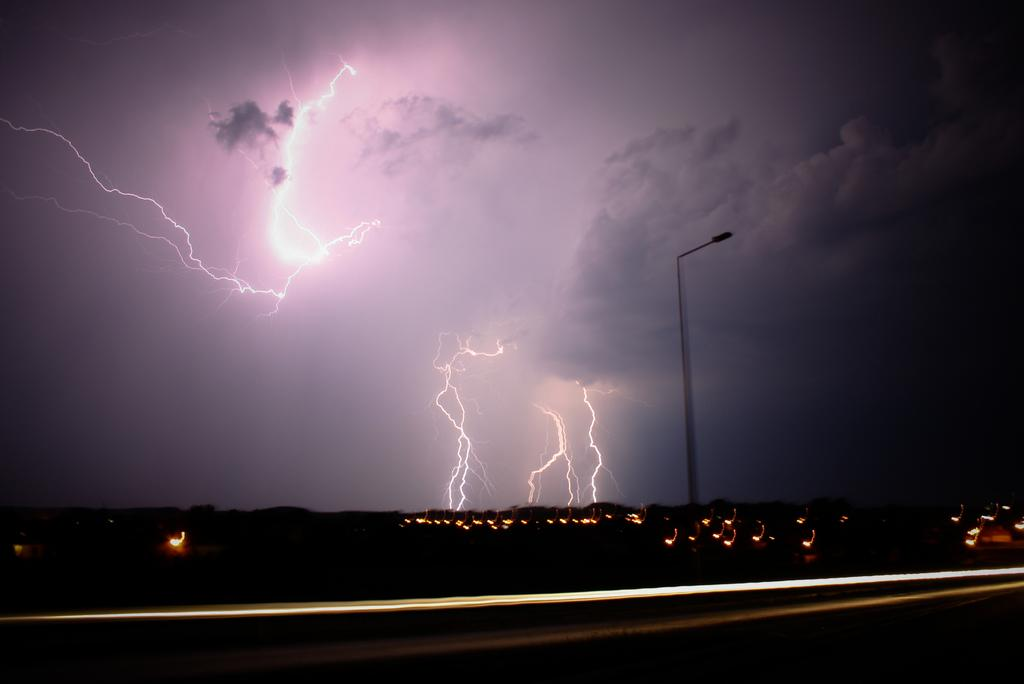What is the main object in the image? There is a pole in the image. What can be seen in the background of the image? There are clouds and thunders visible in the sky in the background of the image. What type of zinc is being used to create the bottle in the image? There is no bottle present in the image, and therefore no zinc or cracking is involved. 